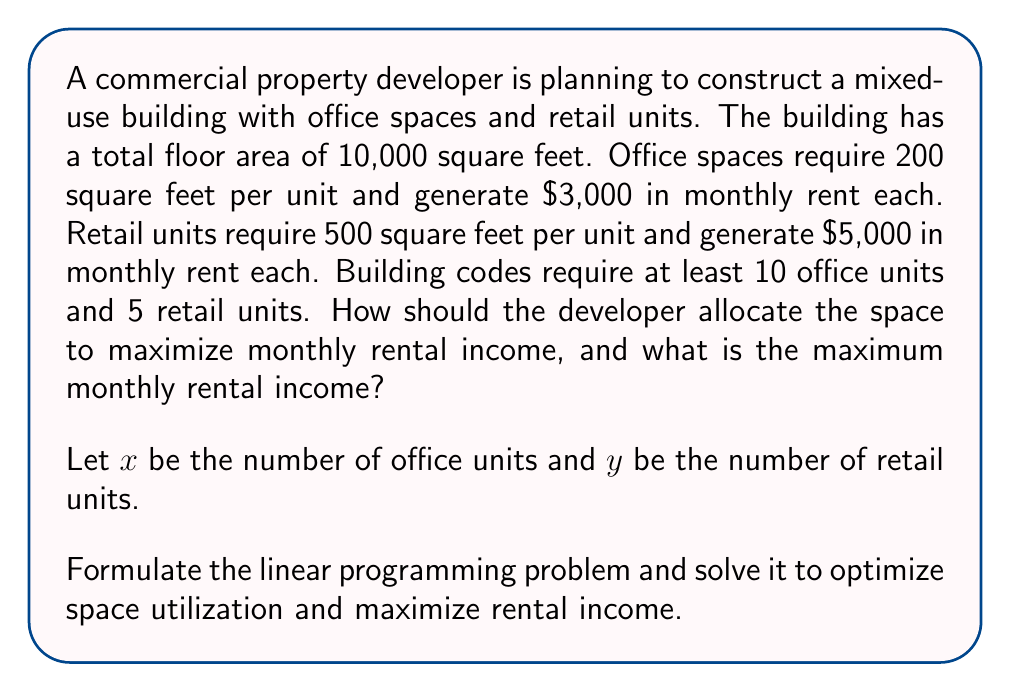Could you help me with this problem? Step 1: Define the objective function
The goal is to maximize monthly rental income:
$$Z = 3000x + 5000y$$

Step 2: Identify constraints
a) Total floor area constraint:
$$200x + 500y \leq 10000$$

b) Minimum number of units constraints:
$$x \geq 10$$
$$y \geq 5$$

c) Non-negativity constraints:
$$x \geq 0, y \geq 0$$

Step 3: Set up the linear programming problem
Maximize: $Z = 3000x + 5000y$
Subject to:
$$200x + 500y \leq 10000$$
$$x \geq 10$$
$$y \geq 5$$
$$x, y \geq 0$$

Step 4: Solve using the graphical method
Plot the constraints on a coordinate system:

[asy]
size(200);
draw((0,0)--(50,0),Arrow);
draw((0,0)--(0,20),Arrow);
label("x",((50,0)),E);
label("y",((0,20)),N);
draw((0,20)--(50,0),red);
draw((10,0)--(10,20),blue);
draw((0,5)--(50,5),green);
label("200x + 500y = 10000",(25,10),NW,red);
label("x = 10",(10,10),E,blue);
label("y = 5",(25,5),N,green);
dot((10,16));
dot((25,10));
label("(10,16)",(10,16),NE);
label("(25,10)",(25,10),SE);
[/asy]

Step 5: Identify feasible region and corner points
The feasible region is bounded by the constraints. The corner points are (10,16) and (25,10).

Step 6: Evaluate the objective function at corner points
At (10,16): $Z = 3000(10) + 5000(16) = 110,000$
At (25,10): $Z = 3000(25) + 5000(10) = 125,000$

Step 7: Determine the optimal solution
The maximum value of Z occurs at (25,10), which represents 25 office units and 10 retail units.
Answer: 25 office units, 10 retail units; $125,000 monthly rental income 